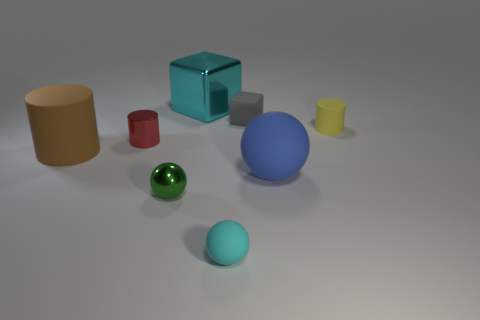Is the shape of the red metal thing the same as the yellow thing that is in front of the big cyan metallic thing?
Provide a succinct answer. Yes. What number of objects are matte balls in front of the blue sphere or small things behind the small cyan matte thing?
Provide a short and direct response. 5. What is the material of the red thing?
Offer a very short reply. Metal. What number of other objects are the same size as the red cylinder?
Offer a very short reply. 4. There is a rubber cylinder that is to the right of the tiny gray object; what is its size?
Offer a very short reply. Small. What is the material of the cyan thing that is in front of the big rubber thing left of the small rubber sphere in front of the small metal sphere?
Your answer should be compact. Rubber. Does the tiny green metallic thing have the same shape as the large brown rubber object?
Ensure brevity in your answer.  No. What number of matte objects are either gray cubes or tiny green objects?
Offer a very short reply. 1. What number of small rubber objects are there?
Provide a short and direct response. 3. What is the color of the block that is the same size as the green object?
Ensure brevity in your answer.  Gray. 